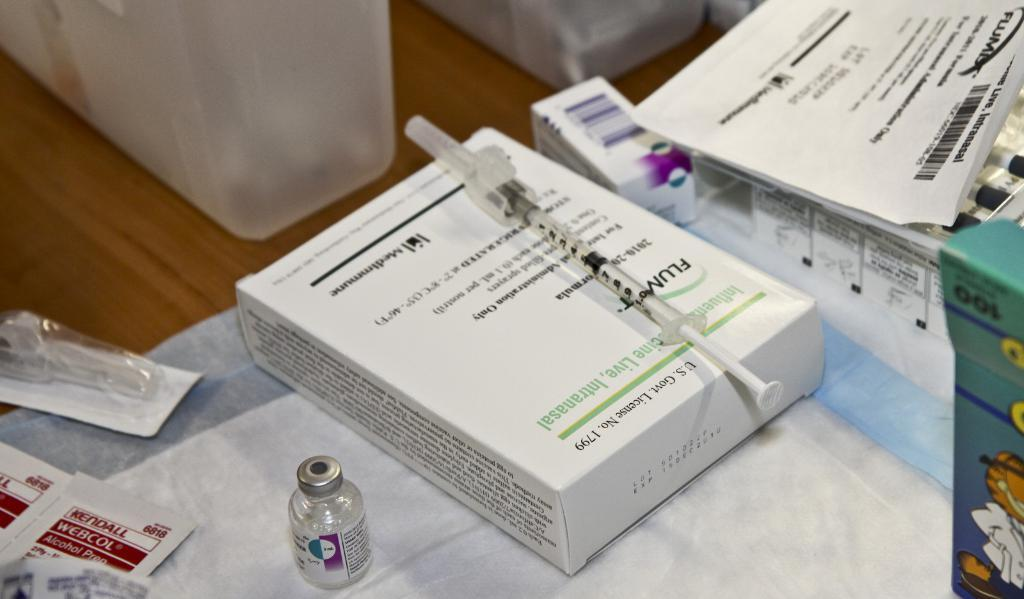Provide a one-sentence caption for the provided image. a medical table has WEBCOL alcohol prep wipes and a syringe of something. 